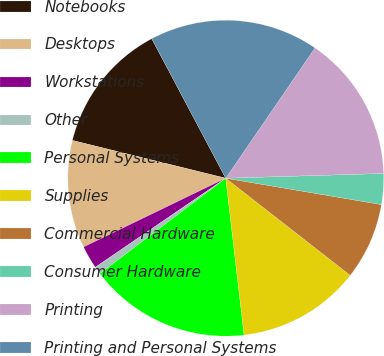<chart> <loc_0><loc_0><loc_500><loc_500><pie_chart><fcel>Notebooks<fcel>Desktops<fcel>Workstations<fcel>Other<fcel>Personal Systems<fcel>Supplies<fcel>Commercial Hardware<fcel>Consumer Hardware<fcel>Printing<fcel>Printing and Personal Systems<nl><fcel>13.39%<fcel>11.02%<fcel>2.36%<fcel>0.79%<fcel>16.53%<fcel>12.6%<fcel>7.87%<fcel>3.15%<fcel>14.96%<fcel>17.32%<nl></chart> 